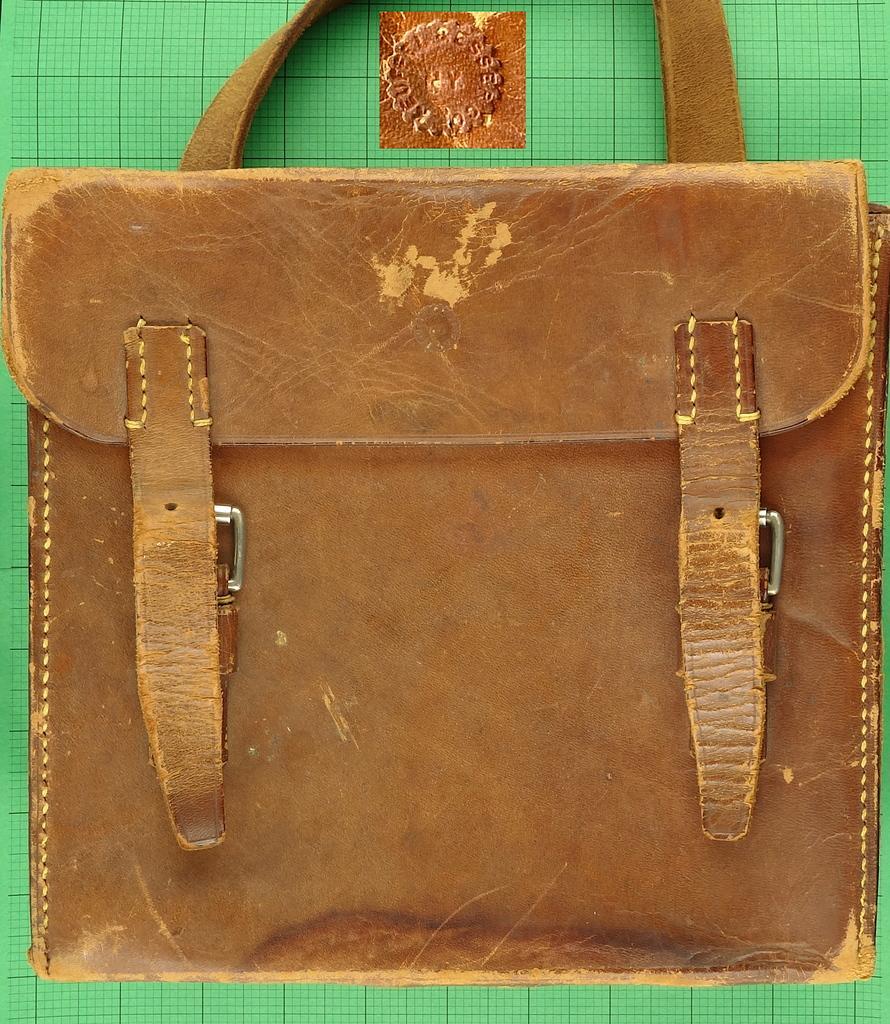Please provide a concise description of this image. In this image I can see a brown color of handbag. 